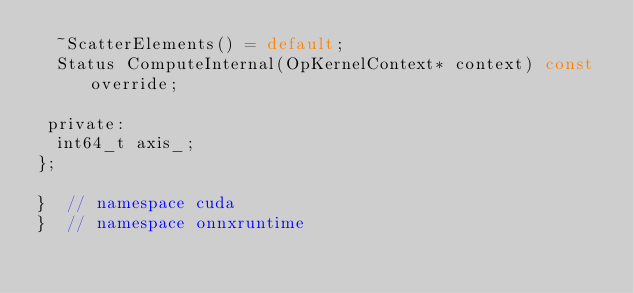Convert code to text. <code><loc_0><loc_0><loc_500><loc_500><_C_>  ~ScatterElements() = default;
  Status ComputeInternal(OpKernelContext* context) const override;

 private:
  int64_t axis_;
};

}  // namespace cuda
}  // namespace onnxruntime

</code> 